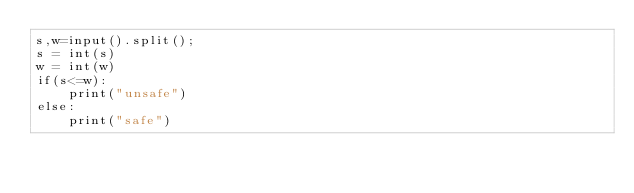Convert code to text. <code><loc_0><loc_0><loc_500><loc_500><_Python_>s,w=input().split();
s = int(s)
w = int(w)
if(s<=w):
    print("unsafe")
else:
    print("safe")
</code> 